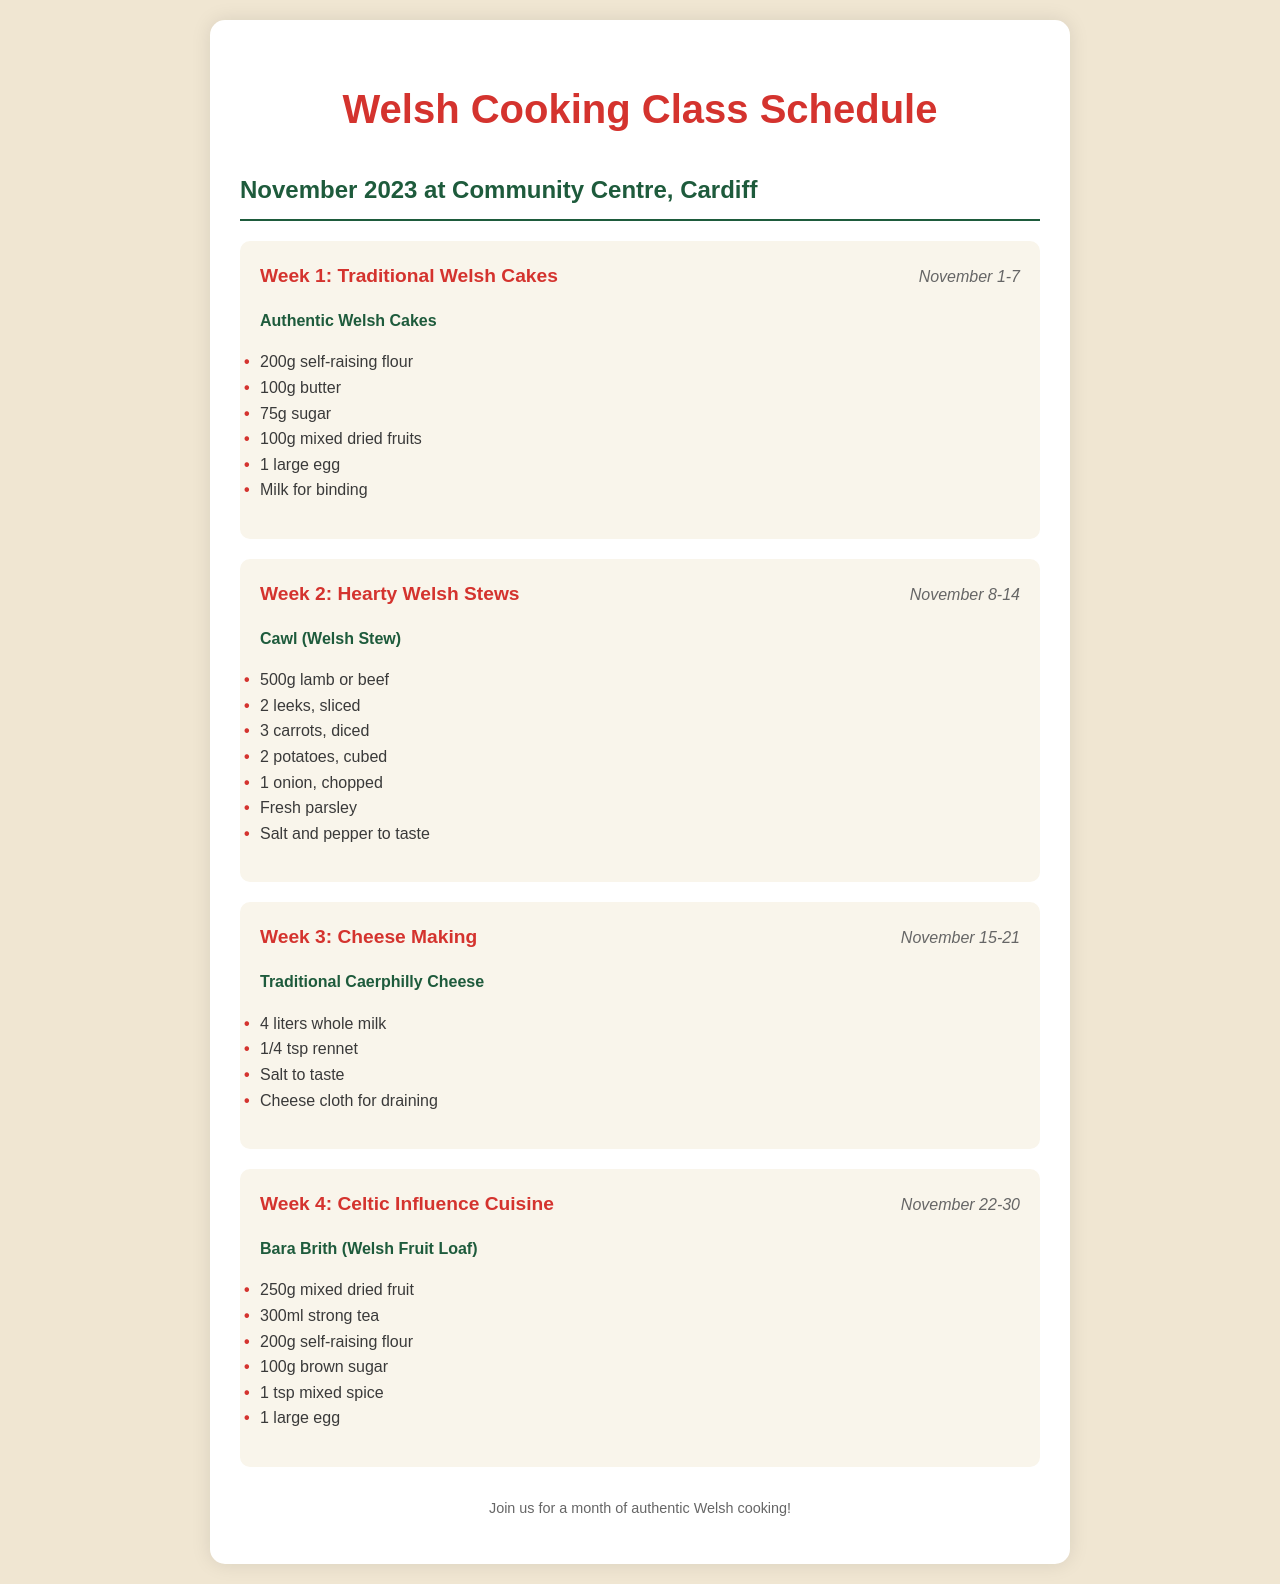What is the theme for Week 1? The theme for Week 1 is specified at the beginning of the week section, which is Traditional Welsh Cakes.
Answer: Traditional Welsh Cakes What are the dates for Week 3? The dates for Week 3 are listed next to the week title, which indicates November 15-21.
Answer: November 15-21 What is one of the ingredients for Cawl? Cawl (Welsh Stew) is listed in Week 2, and one of the ingredients is available in the recipe section.
Answer: 500g lamb or beef How many liters of milk are needed for making Caerphilly Cheese? The amount of milk required for Traditional Caerphilly Cheese is directly included in the ingredient list as 4 liters.
Answer: 4 liters What is the recipe name for Week 4? The recipe name can be found in Week 4's section, indicating the dish being made during that week.
Answer: Bara Brith How many ingredients are listed for making Welsh Cakes? By counting the items in the ingredient list for Welsh Cakes in Week 1, we determine the number of ingredients required.
Answer: 6 What is the last day of the cooking classes in November? The last day is provided in the date section of Week 4, specifying the end of the month.
Answer: November 30 Which dish is associated with Week 2? The dish associated with Week 2 is mentioned just below the week theme and is explicitly named in the document.
Answer: Cawl (Welsh Stew) What type of cuisine is focused on in Week 4? The theme in Week 4 details the type of cuisine being highlighted, which can be found in the week title.
Answer: Celtic Influence Cuisine 